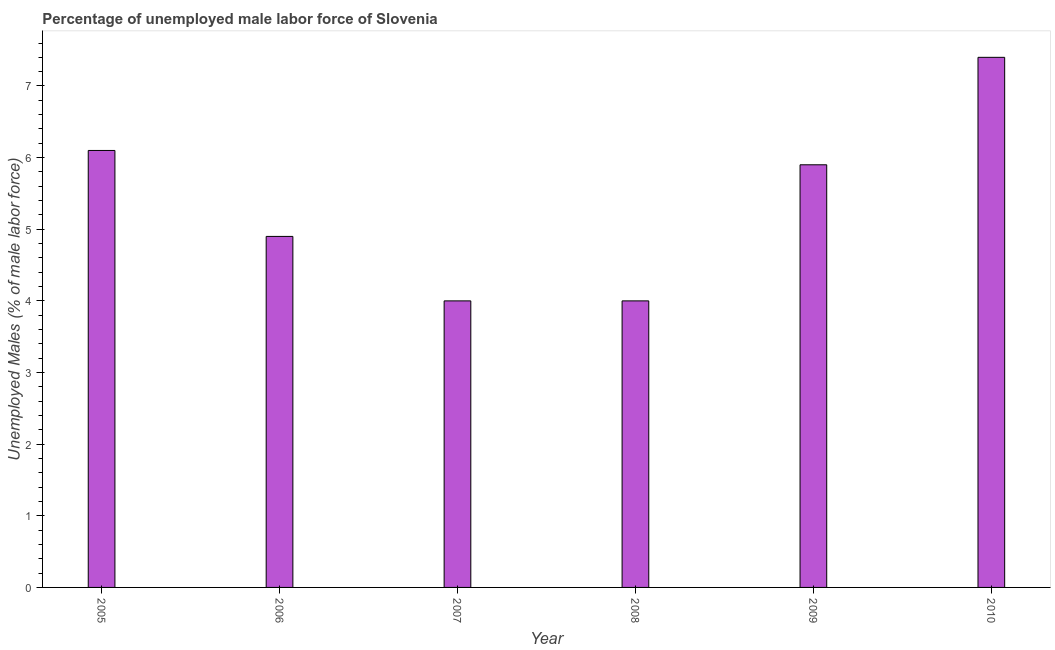What is the title of the graph?
Offer a terse response. Percentage of unemployed male labor force of Slovenia. What is the label or title of the Y-axis?
Ensure brevity in your answer.  Unemployed Males (% of male labor force). What is the total unemployed male labour force in 2009?
Your answer should be very brief. 5.9. Across all years, what is the maximum total unemployed male labour force?
Your answer should be very brief. 7.4. Across all years, what is the minimum total unemployed male labour force?
Keep it short and to the point. 4. In which year was the total unemployed male labour force maximum?
Your answer should be very brief. 2010. What is the sum of the total unemployed male labour force?
Ensure brevity in your answer.  32.3. What is the average total unemployed male labour force per year?
Ensure brevity in your answer.  5.38. What is the median total unemployed male labour force?
Keep it short and to the point. 5.4. Do a majority of the years between 2009 and 2005 (inclusive) have total unemployed male labour force greater than 3.2 %?
Keep it short and to the point. Yes. What is the ratio of the total unemployed male labour force in 2006 to that in 2009?
Ensure brevity in your answer.  0.83. Is the total unemployed male labour force in 2005 less than that in 2010?
Provide a succinct answer. Yes. Is the difference between the total unemployed male labour force in 2009 and 2010 greater than the difference between any two years?
Provide a succinct answer. No. Is the sum of the total unemployed male labour force in 2007 and 2008 greater than the maximum total unemployed male labour force across all years?
Offer a very short reply. Yes. In how many years, is the total unemployed male labour force greater than the average total unemployed male labour force taken over all years?
Offer a very short reply. 3. What is the difference between two consecutive major ticks on the Y-axis?
Provide a succinct answer. 1. Are the values on the major ticks of Y-axis written in scientific E-notation?
Give a very brief answer. No. What is the Unemployed Males (% of male labor force) in 2005?
Give a very brief answer. 6.1. What is the Unemployed Males (% of male labor force) of 2006?
Give a very brief answer. 4.9. What is the Unemployed Males (% of male labor force) of 2007?
Your answer should be very brief. 4. What is the Unemployed Males (% of male labor force) in 2009?
Your answer should be compact. 5.9. What is the Unemployed Males (% of male labor force) of 2010?
Ensure brevity in your answer.  7.4. What is the difference between the Unemployed Males (% of male labor force) in 2005 and 2006?
Offer a terse response. 1.2. What is the difference between the Unemployed Males (% of male labor force) in 2005 and 2007?
Offer a very short reply. 2.1. What is the difference between the Unemployed Males (% of male labor force) in 2006 and 2009?
Offer a terse response. -1. What is the difference between the Unemployed Males (% of male labor force) in 2006 and 2010?
Provide a short and direct response. -2.5. What is the difference between the Unemployed Males (% of male labor force) in 2007 and 2008?
Provide a short and direct response. 0. What is the difference between the Unemployed Males (% of male labor force) in 2007 and 2010?
Offer a very short reply. -3.4. What is the difference between the Unemployed Males (% of male labor force) in 2008 and 2010?
Make the answer very short. -3.4. What is the difference between the Unemployed Males (% of male labor force) in 2009 and 2010?
Offer a very short reply. -1.5. What is the ratio of the Unemployed Males (% of male labor force) in 2005 to that in 2006?
Provide a succinct answer. 1.25. What is the ratio of the Unemployed Males (% of male labor force) in 2005 to that in 2007?
Your answer should be compact. 1.52. What is the ratio of the Unemployed Males (% of male labor force) in 2005 to that in 2008?
Make the answer very short. 1.52. What is the ratio of the Unemployed Males (% of male labor force) in 2005 to that in 2009?
Make the answer very short. 1.03. What is the ratio of the Unemployed Males (% of male labor force) in 2005 to that in 2010?
Give a very brief answer. 0.82. What is the ratio of the Unemployed Males (% of male labor force) in 2006 to that in 2007?
Give a very brief answer. 1.23. What is the ratio of the Unemployed Males (% of male labor force) in 2006 to that in 2008?
Ensure brevity in your answer.  1.23. What is the ratio of the Unemployed Males (% of male labor force) in 2006 to that in 2009?
Offer a terse response. 0.83. What is the ratio of the Unemployed Males (% of male labor force) in 2006 to that in 2010?
Ensure brevity in your answer.  0.66. What is the ratio of the Unemployed Males (% of male labor force) in 2007 to that in 2008?
Give a very brief answer. 1. What is the ratio of the Unemployed Males (% of male labor force) in 2007 to that in 2009?
Provide a short and direct response. 0.68. What is the ratio of the Unemployed Males (% of male labor force) in 2007 to that in 2010?
Offer a terse response. 0.54. What is the ratio of the Unemployed Males (% of male labor force) in 2008 to that in 2009?
Give a very brief answer. 0.68. What is the ratio of the Unemployed Males (% of male labor force) in 2008 to that in 2010?
Your answer should be very brief. 0.54. What is the ratio of the Unemployed Males (% of male labor force) in 2009 to that in 2010?
Provide a short and direct response. 0.8. 